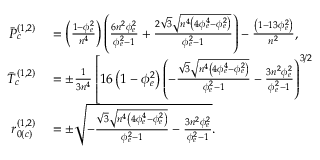Convert formula to latex. <formula><loc_0><loc_0><loc_500><loc_500>\begin{array} { r l } { \ B a r { P } _ { c } ^ { ( 1 , 2 ) } } & = \left ( \frac { 1 - \phi _ { e } ^ { 2 } } { n ^ { 4 } } \right ) \left ( \frac { 6 n ^ { 2 } \phi _ { e } ^ { 2 } } { \phi _ { e } ^ { 2 } - 1 } + \frac { 2 \sqrt { 3 } \sqrt { n ^ { 4 } \left ( 4 \phi _ { e } ^ { 4 } - \phi _ { e } ^ { 2 } \right ) } } { \phi _ { e } ^ { 2 } - 1 } \right ) - \frac { \left ( 1 - 1 3 \phi _ { e } ^ { 2 } \right ) } { n ^ { 2 } } , } \\ { \ B a r { T } _ { c } ^ { ( 1 , 2 ) } } & = \pm \frac { 1 } { 3 n ^ { 4 } } \left [ 1 6 \left ( 1 - \phi _ { e } ^ { 2 } \right ) \left ( - \frac { \sqrt { 3 } \sqrt { n ^ { 4 } \left ( 4 \phi _ { e } ^ { 4 } - \phi _ { e } ^ { 2 } \right ) } } { \phi _ { e } ^ { 2 } - 1 } - \frac { 3 n ^ { 2 } \phi _ { e } ^ { 2 } } { \phi _ { e } ^ { 2 } - 1 } \right ) ^ { 3 / 2 } } \\ { r _ { 0 ( c ) } ^ { ( 1 , 2 ) } } & = \pm \sqrt { - \frac { \sqrt { 3 } \sqrt { n ^ { 4 } \left ( 4 \phi _ { e } ^ { 4 } - \phi _ { e } ^ { 2 } \right ) } } { \phi _ { e } ^ { 2 } - 1 } - \frac { 3 n ^ { 2 } \phi _ { e } ^ { 2 } } { \phi _ { e } ^ { 2 } - 1 } } . } \end{array}</formula> 